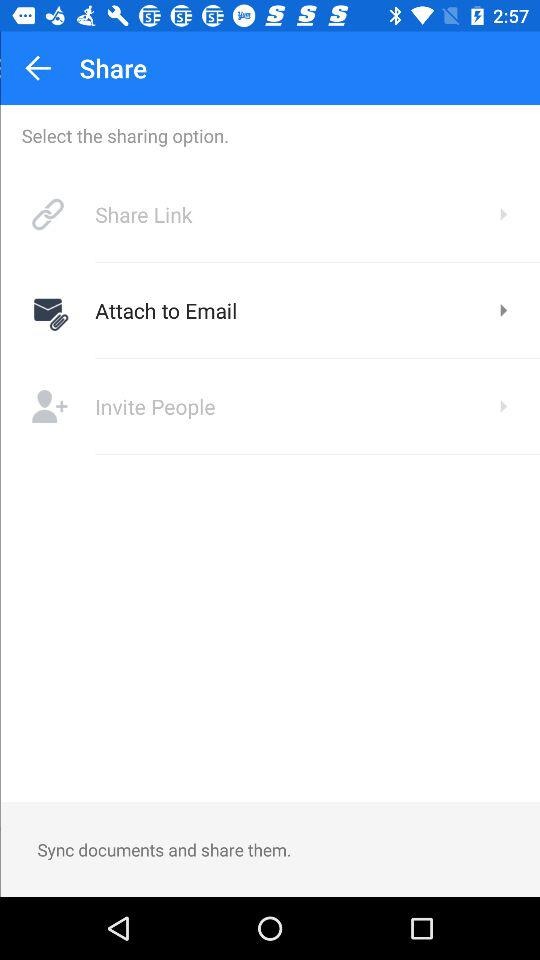What is the selected sharing option? The selected sharing option is "Attach to Email". 